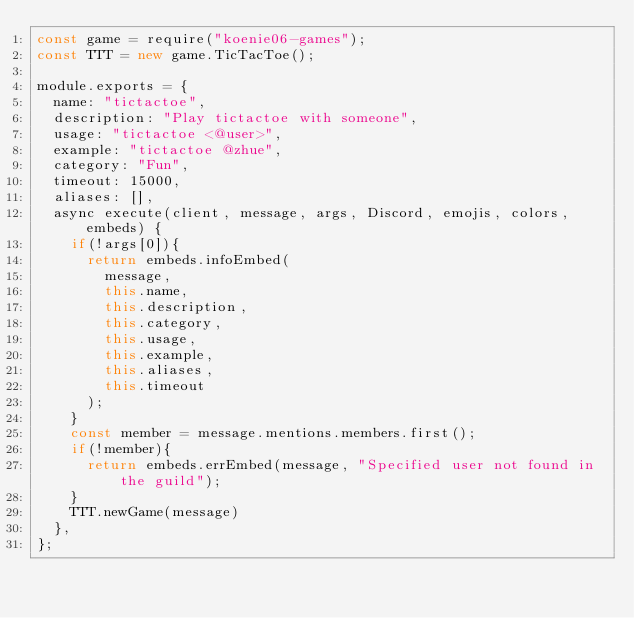Convert code to text. <code><loc_0><loc_0><loc_500><loc_500><_JavaScript_>const game = require("koenie06-games");
const TTT = new game.TicTacToe();

module.exports = {
  name: "tictactoe",
  description: "Play tictactoe with someone",
  usage: "tictactoe <@user>",
  example: "tictactoe @zhue",
  category: "Fun",
  timeout: 15000,
  aliases: [],
  async execute(client, message, args, Discord, emojis, colors, embeds) {
    if(!args[0]){
      return embeds.infoEmbed(
        message,
        this.name,
        this.description,
        this.category,
        this.usage,
        this.example,
        this.aliases,
        this.timeout
      ); 
    } 
    const member = message.mentions.members.first(); 
    if(!member){
      return embeds.errEmbed(message, "Specified user not found in the guild"); 
    }
    TTT.newGame(message)
  },
};
</code> 